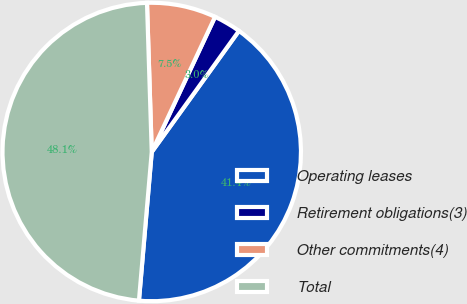Convert chart. <chart><loc_0><loc_0><loc_500><loc_500><pie_chart><fcel>Operating leases<fcel>Retirement obligations(3)<fcel>Other commitments(4)<fcel>Total<nl><fcel>41.44%<fcel>2.96%<fcel>7.48%<fcel>48.13%<nl></chart> 